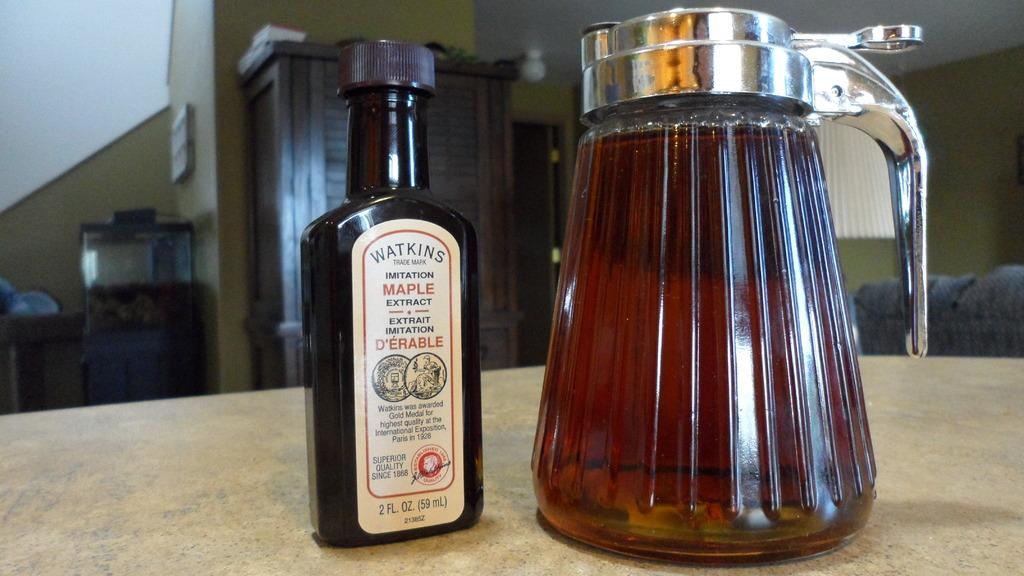What is the main object in the image? There is a bottle in the image. Can you describe the position of the object on a wooden object? There is an object on a wooden object in the image. What else can be seen in the background of the image? There are other objects visible in the background of the image. What time of day is it in the image, based on the presence of teeth? There is no mention of teeth in the image, so it is not possible to determine the time of day based on that information. 